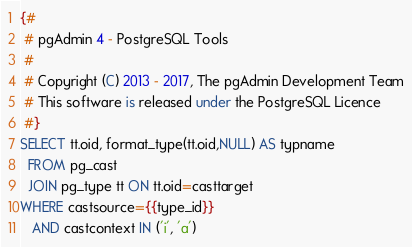Convert code to text. <code><loc_0><loc_0><loc_500><loc_500><_SQL_>{#
 # pgAdmin 4 - PostgreSQL Tools
 #
 # Copyright (C) 2013 - 2017, The pgAdmin Development Team
 # This software is released under the PostgreSQL Licence
 #}
SELECT tt.oid, format_type(tt.oid,NULL) AS typname
  FROM pg_cast
  JOIN pg_type tt ON tt.oid=casttarget
WHERE castsource={{type_id}}
   AND castcontext IN ('i', 'a')</code> 